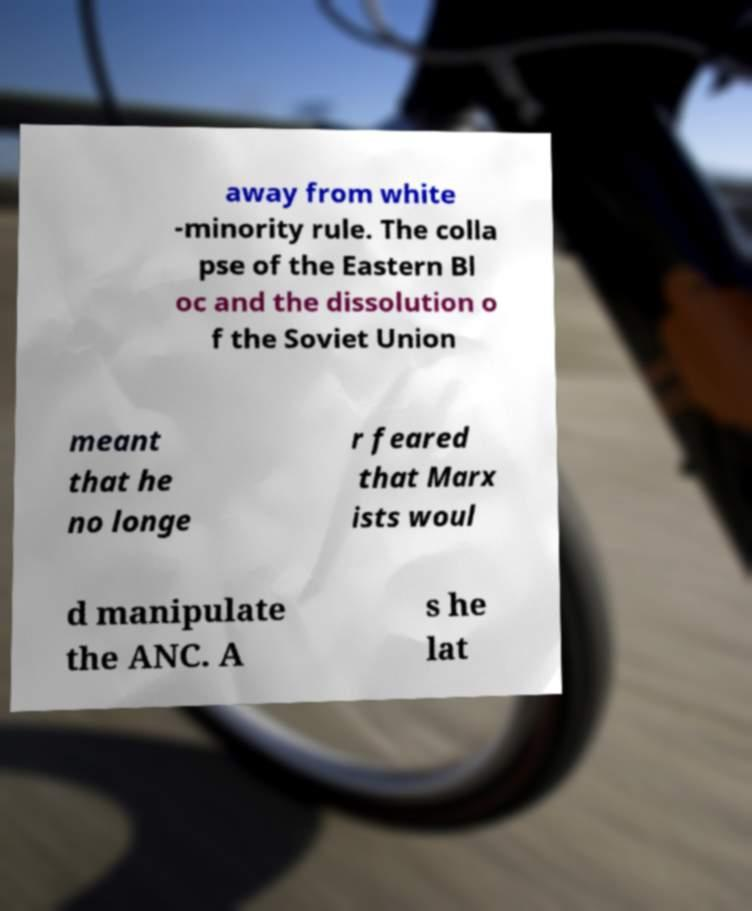Please identify and transcribe the text found in this image. away from white -minority rule. The colla pse of the Eastern Bl oc and the dissolution o f the Soviet Union meant that he no longe r feared that Marx ists woul d manipulate the ANC. A s he lat 